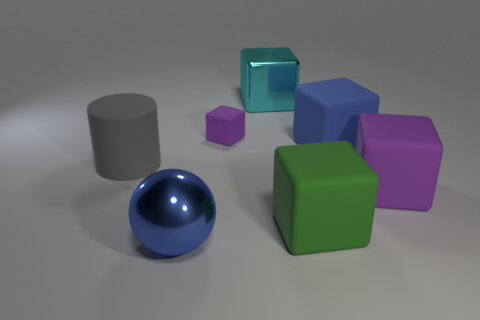Subtract all cyan blocks. How many blocks are left? 4 Subtract all large green cubes. How many cubes are left? 4 Subtract all brown cubes. Subtract all red cylinders. How many cubes are left? 5 Add 2 matte cylinders. How many objects exist? 9 Subtract all blocks. How many objects are left? 2 Subtract 0 green cylinders. How many objects are left? 7 Subtract all tiny blue rubber cubes. Subtract all cyan cubes. How many objects are left? 6 Add 7 cyan shiny things. How many cyan shiny things are left? 8 Add 3 green metal objects. How many green metal objects exist? 3 